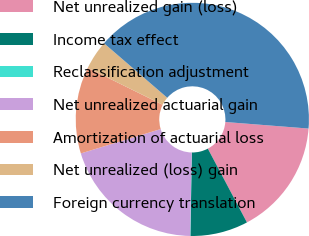Convert chart to OTSL. <chart><loc_0><loc_0><loc_500><loc_500><pie_chart><fcel>Net unrealized gain (loss)<fcel>Income tax effect<fcel>Reclassification adjustment<fcel>Net unrealized actuarial gain<fcel>Amortization of actuarial loss<fcel>Net unrealized (loss) gain<fcel>Foreign currency translation<nl><fcel>16.0%<fcel>8.02%<fcel>0.04%<fcel>19.99%<fcel>12.01%<fcel>4.03%<fcel>39.94%<nl></chart> 